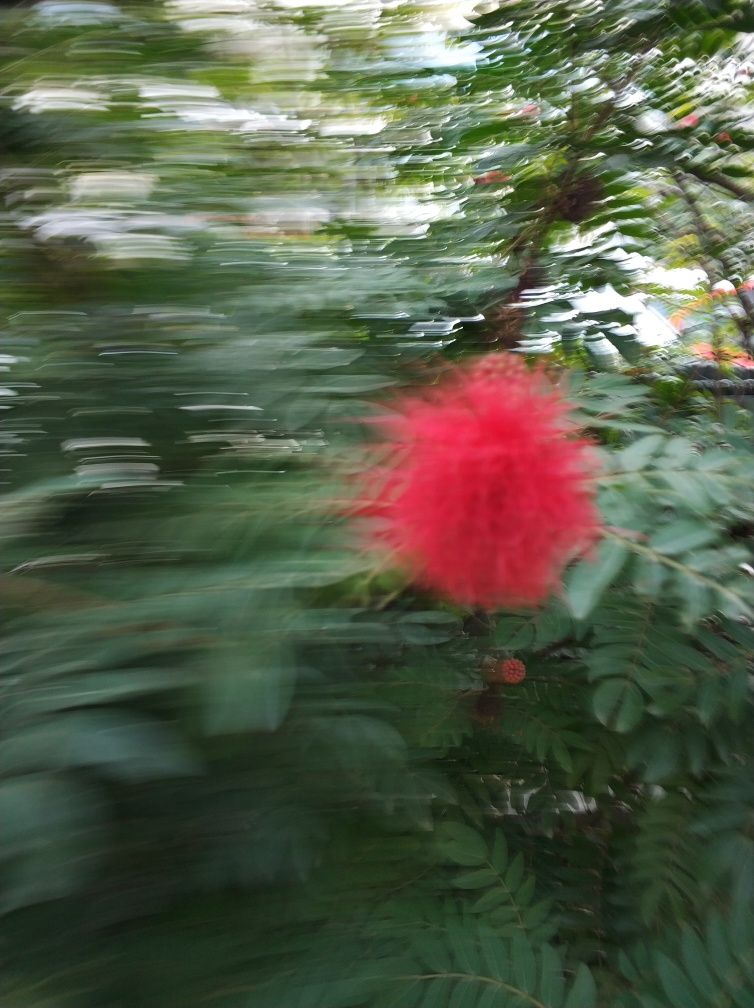Are the shadows well-defined?
A. Yes
B. No While the photo clearly indicates motion blur rather than well-defined shadows due to the apparent camera movement while capturing the image, discerning the shadows accurately is challenging. It would be almost as though the shadows are swept across the field of view along with the foliage, consequently making them poorly defined. Therefore, the most suitable answer, considering the context provided in the original question, would be 'B. No.' 